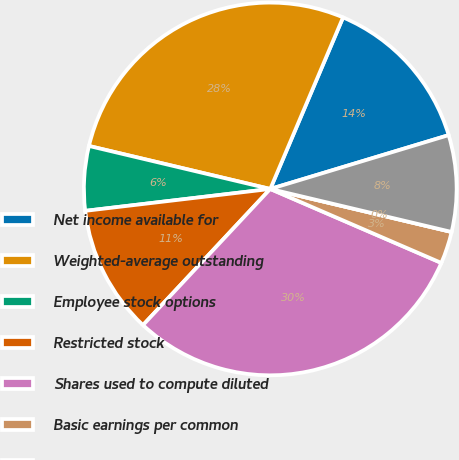Convert chart. <chart><loc_0><loc_0><loc_500><loc_500><pie_chart><fcel>Net income available for<fcel>Weighted-average outstanding<fcel>Employee stock options<fcel>Restricted stock<fcel>Shares used to compute diluted<fcel>Basic earnings per common<fcel>Diluted earnings per common<fcel>Number of antidilutive stock<nl><fcel>13.95%<fcel>27.68%<fcel>5.58%<fcel>11.16%<fcel>30.47%<fcel>2.79%<fcel>0.0%<fcel>8.37%<nl></chart> 